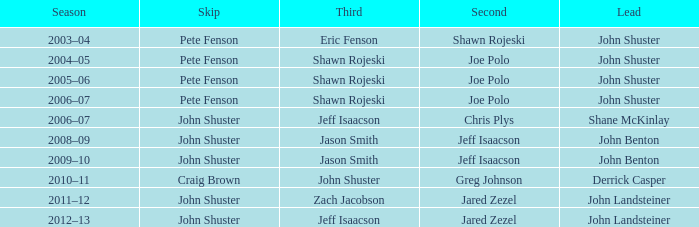When shane mckinlay was in the lead, who came in second place? Chris Plys. Parse the table in full. {'header': ['Season', 'Skip', 'Third', 'Second', 'Lead'], 'rows': [['2003–04', 'Pete Fenson', 'Eric Fenson', 'Shawn Rojeski', 'John Shuster'], ['2004–05', 'Pete Fenson', 'Shawn Rojeski', 'Joe Polo', 'John Shuster'], ['2005–06', 'Pete Fenson', 'Shawn Rojeski', 'Joe Polo', 'John Shuster'], ['2006–07', 'Pete Fenson', 'Shawn Rojeski', 'Joe Polo', 'John Shuster'], ['2006–07', 'John Shuster', 'Jeff Isaacson', 'Chris Plys', 'Shane McKinlay'], ['2008–09', 'John Shuster', 'Jason Smith', 'Jeff Isaacson', 'John Benton'], ['2009–10', 'John Shuster', 'Jason Smith', 'Jeff Isaacson', 'John Benton'], ['2010–11', 'Craig Brown', 'John Shuster', 'Greg Johnson', 'Derrick Casper'], ['2011–12', 'John Shuster', 'Zach Jacobson', 'Jared Zezel', 'John Landsteiner'], ['2012–13', 'John Shuster', 'Jeff Isaacson', 'Jared Zezel', 'John Landsteiner']]} 